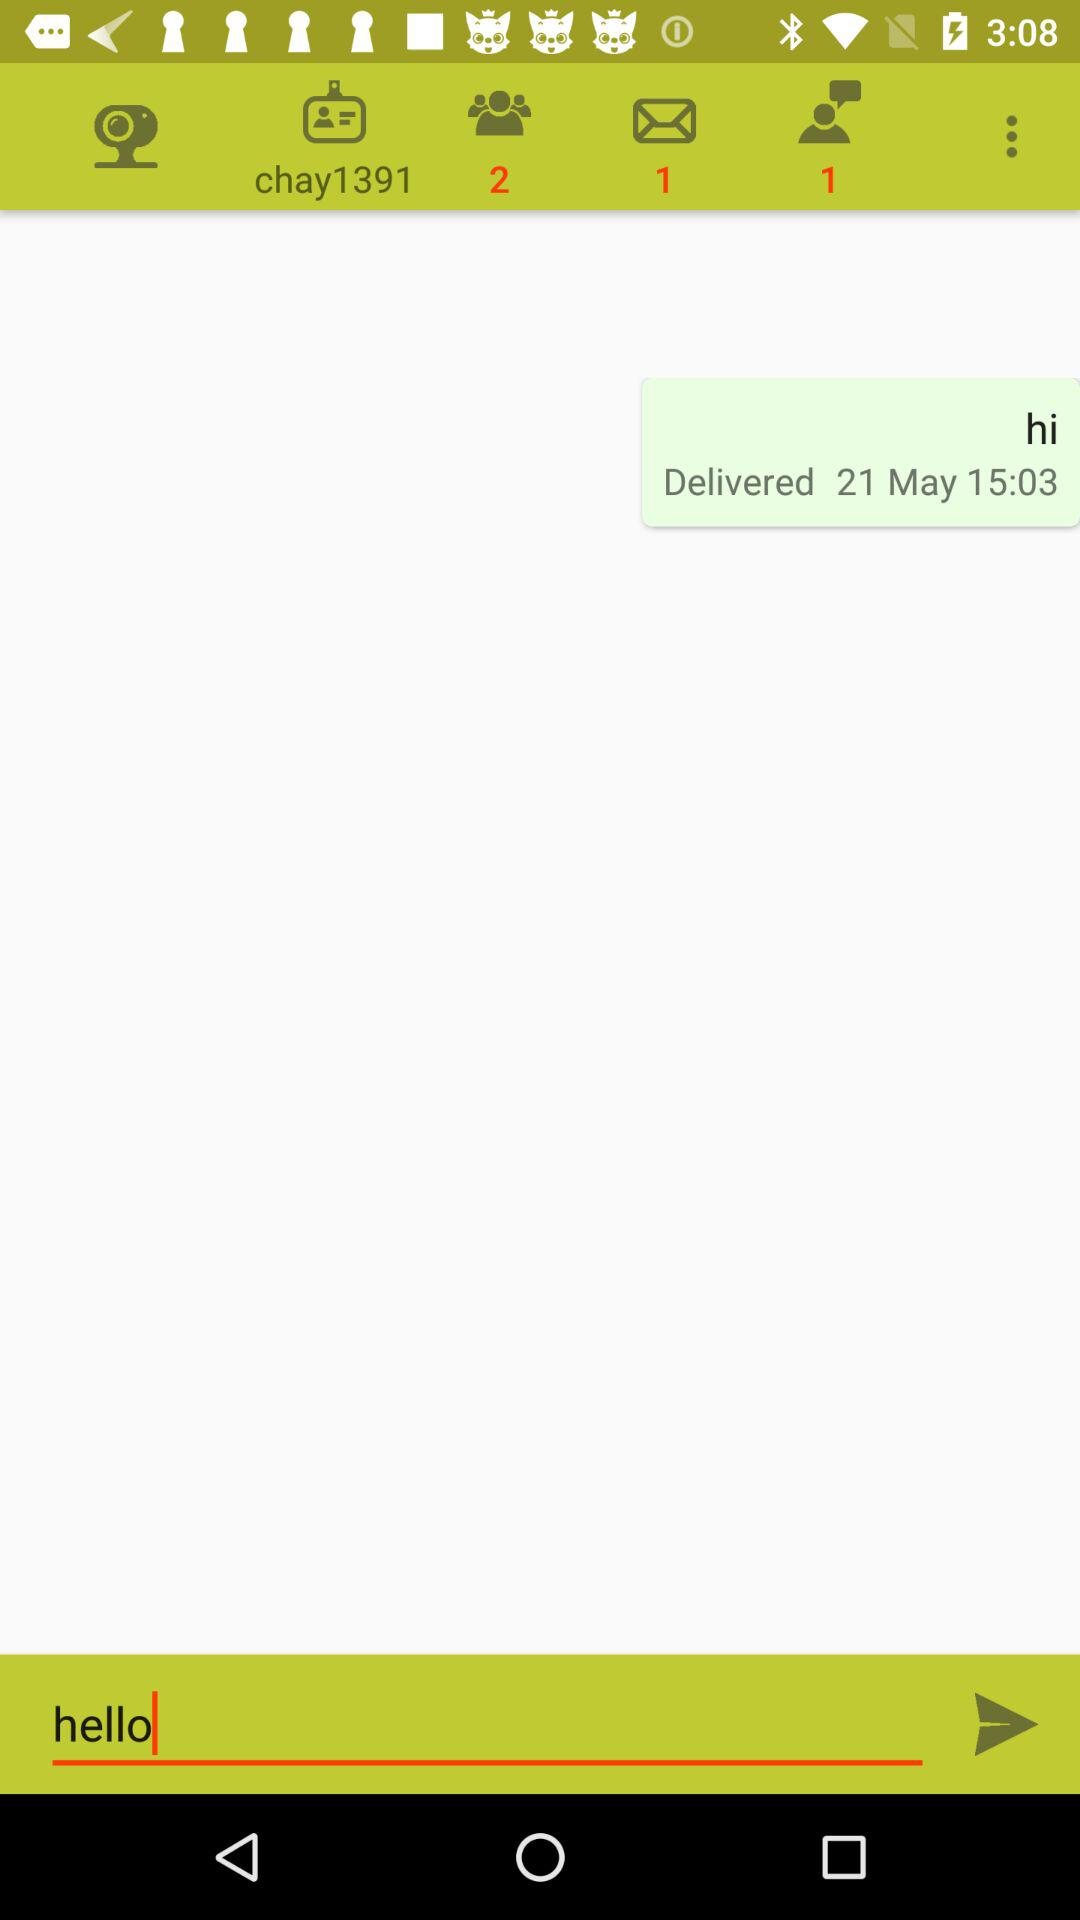How many more messages do I have than emails?
Answer the question using a single word or phrase. 1 